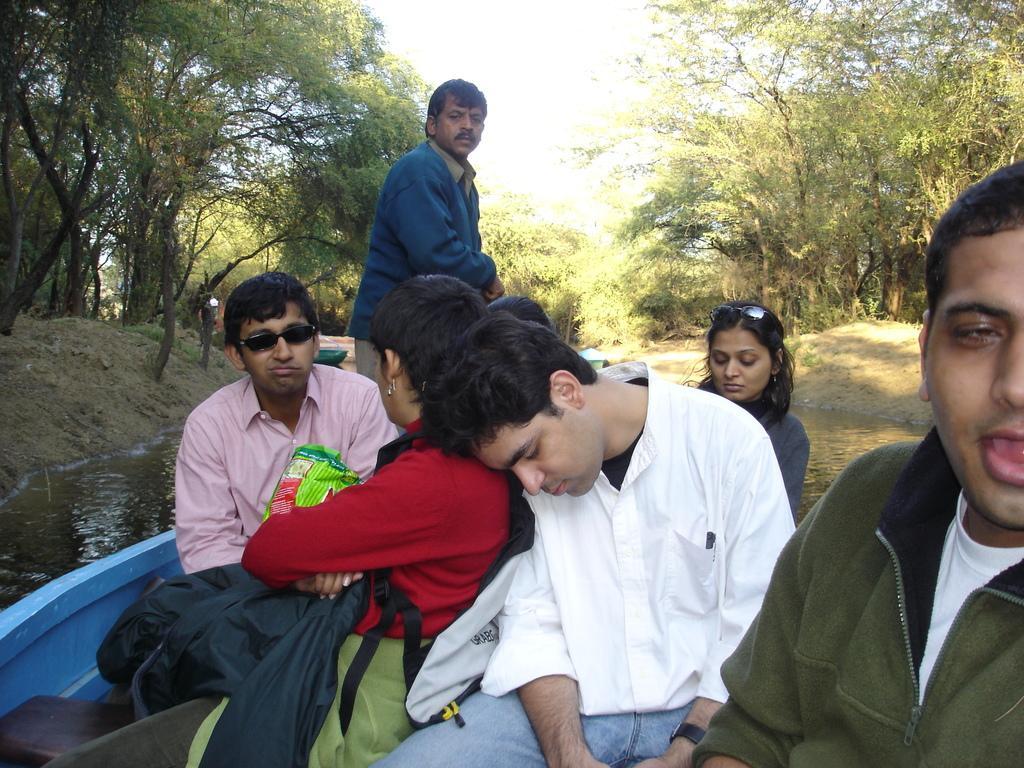How would you summarize this image in a sentence or two? In this picture we can see few boats on the water, and we can find few people in the boat, in the background we can see few trees. 